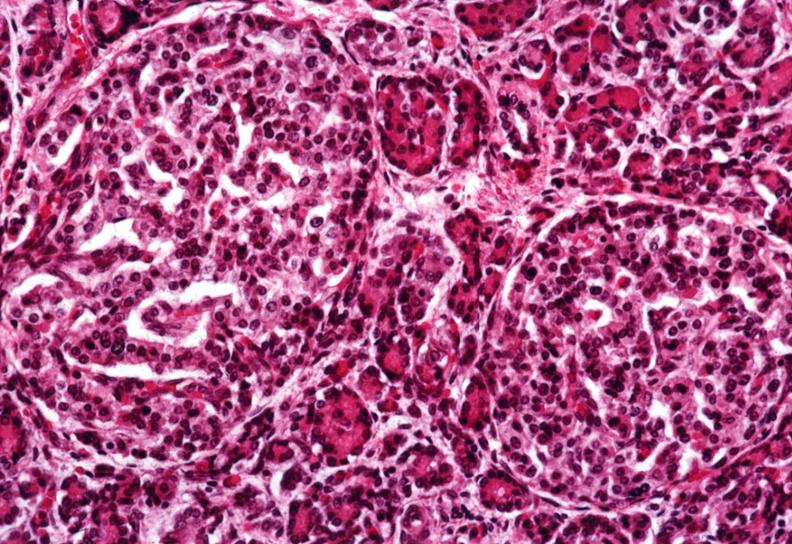does this image show two quite large islets?
Answer the question using a single word or phrase. Yes 